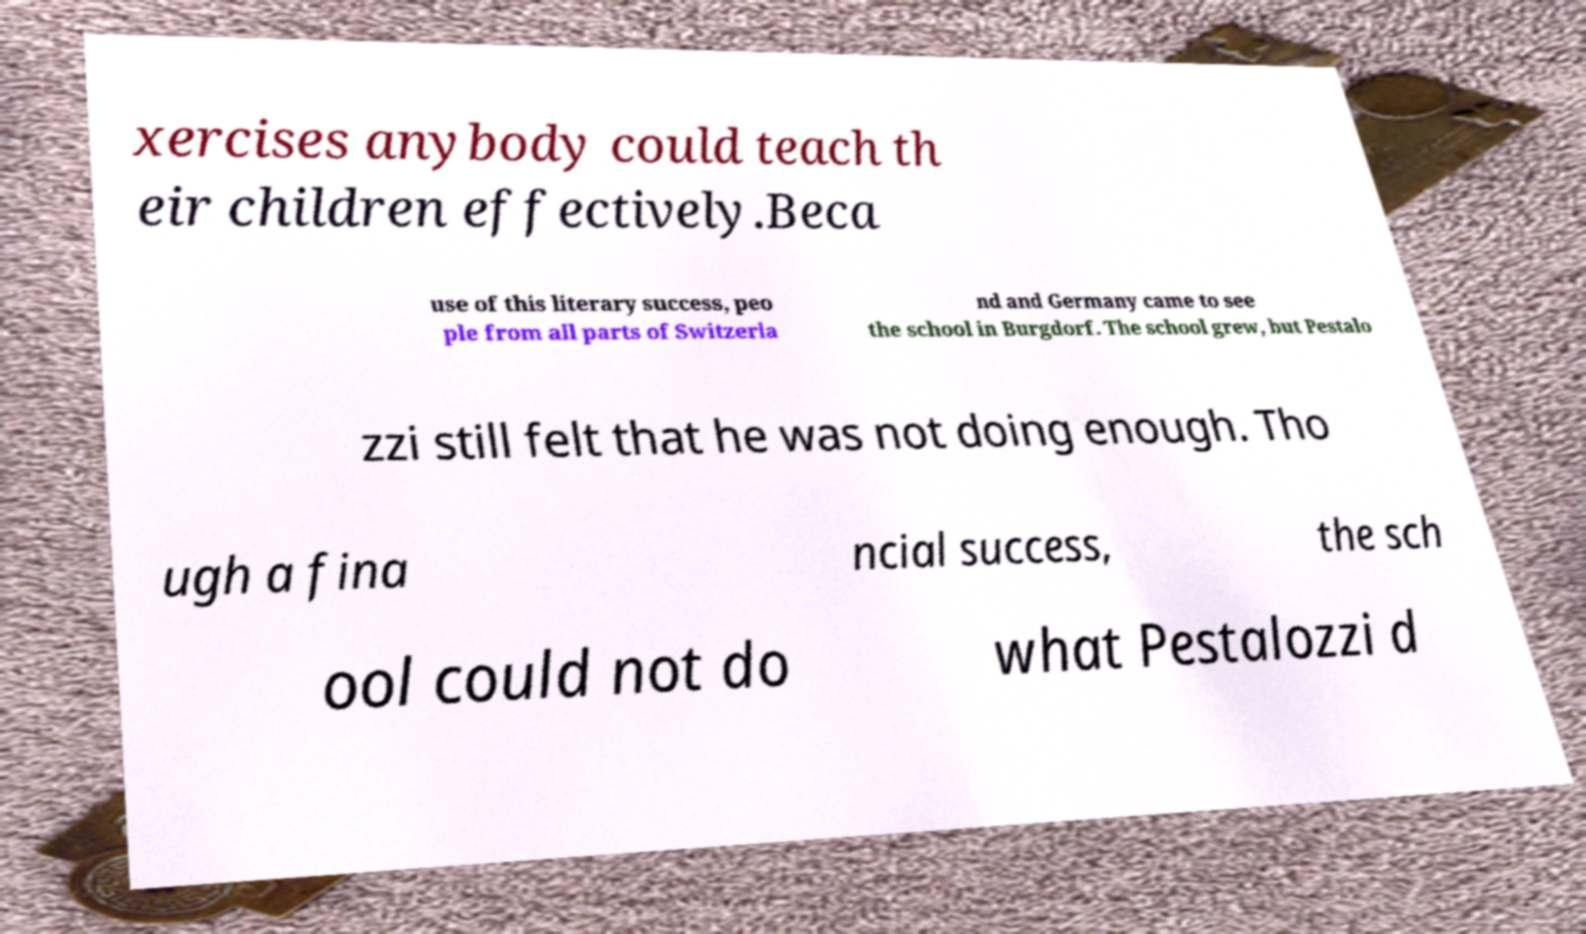Could you extract and type out the text from this image? xercises anybody could teach th eir children effectively.Beca use of this literary success, peo ple from all parts of Switzerla nd and Germany came to see the school in Burgdorf. The school grew, but Pestalo zzi still felt that he was not doing enough. Tho ugh a fina ncial success, the sch ool could not do what Pestalozzi d 